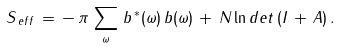Convert formula to latex. <formula><loc_0><loc_0><loc_500><loc_500>S _ { \, e f f } \, = \, - \, \pi \, \sum _ { \omega } \, b ^ { \, * } ( \omega ) \, b ( \omega ) \, + \, N \ln { d e t \, ( I \, + \, A ) } \, .</formula> 